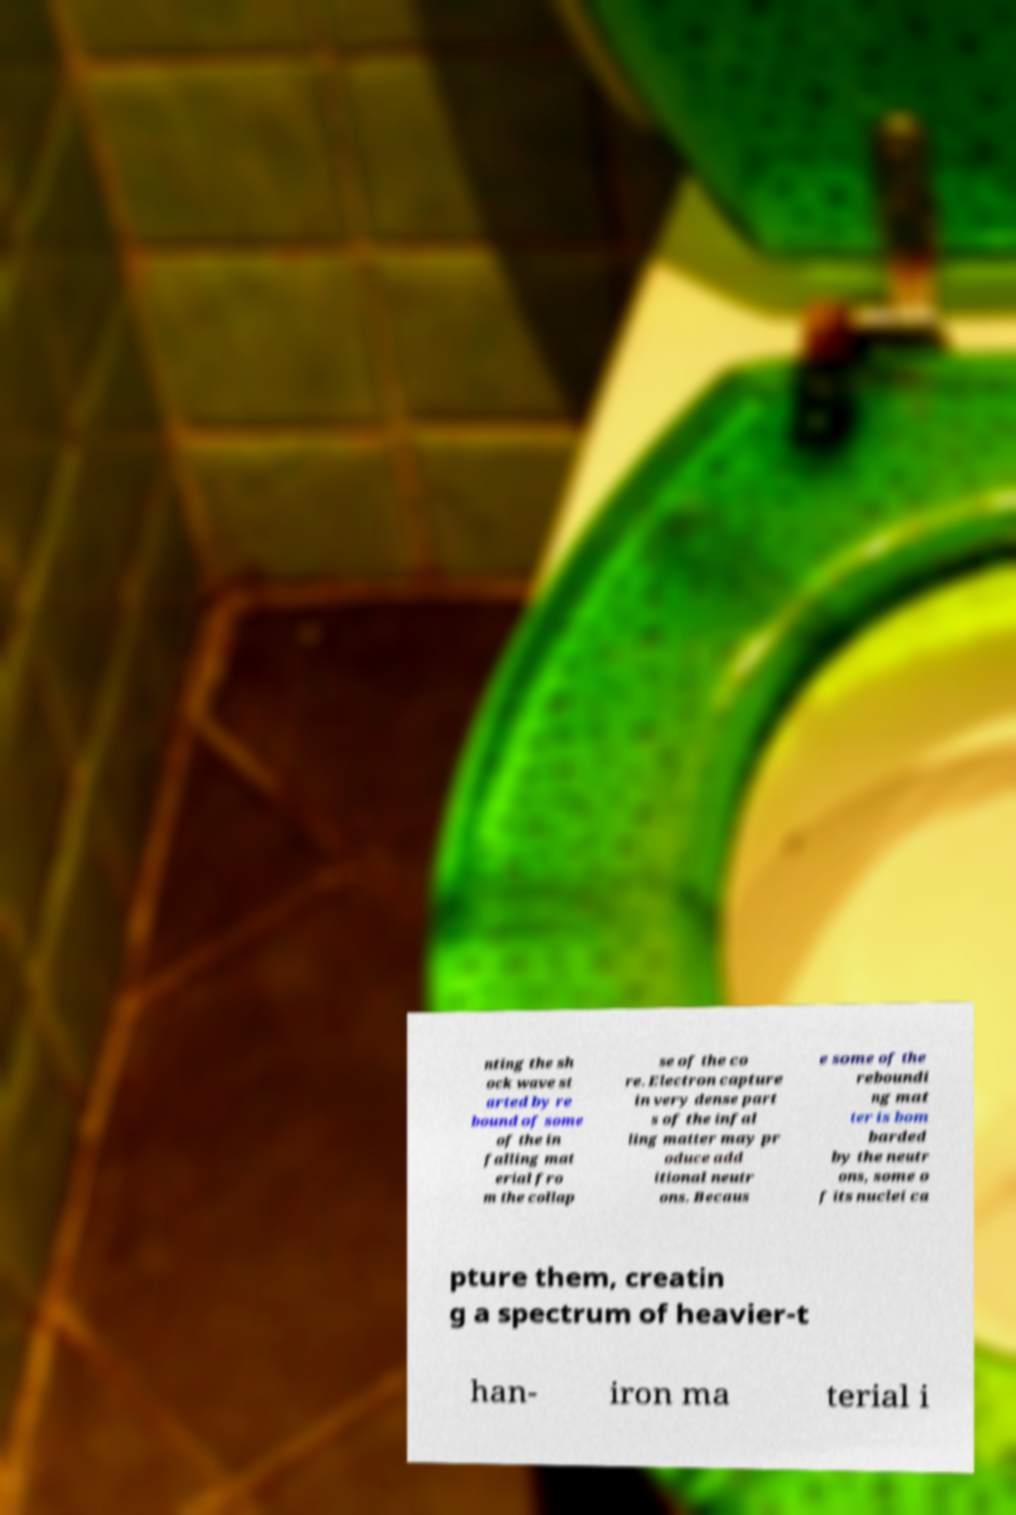Please read and relay the text visible in this image. What does it say? nting the sh ock wave st arted by re bound of some of the in falling mat erial fro m the collap se of the co re. Electron capture in very dense part s of the infal ling matter may pr oduce add itional neutr ons. Becaus e some of the reboundi ng mat ter is bom barded by the neutr ons, some o f its nuclei ca pture them, creatin g a spectrum of heavier-t han- iron ma terial i 